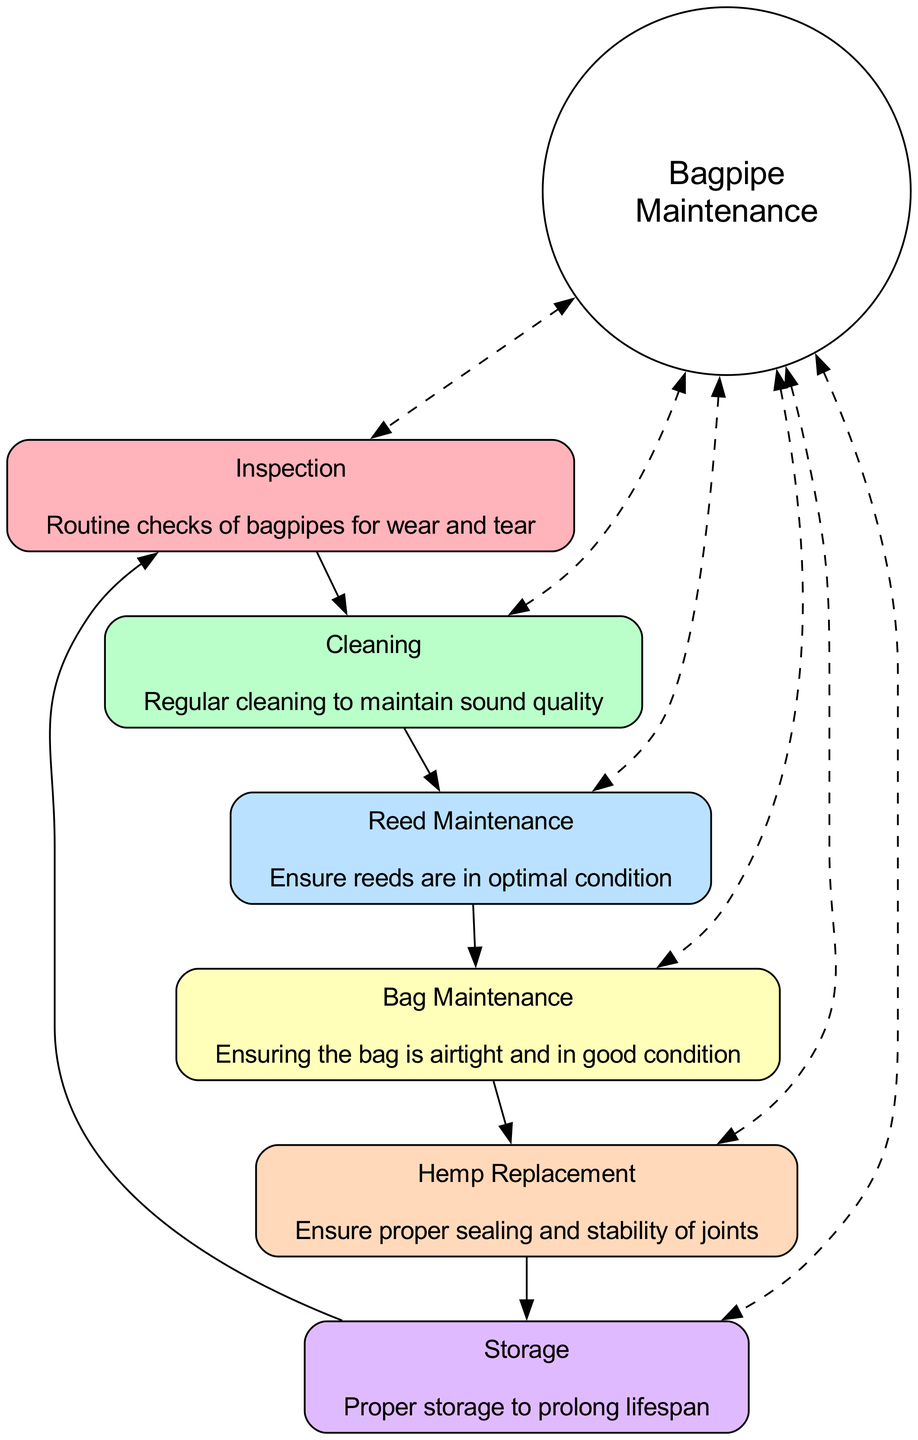What is the first step in the maintenance cycle? The diagram shows that "Inspection" is the first element in the cycle, meaning it is the first step in the maintenance process for bagpipes.
Answer: Inspection How many total elements are in the maintenance cycle? By counting the elements listed in the diagram, there are six key components that make up the maintenance cycle for bagpipes.
Answer: 6 What connects "Bag Maintenance" to "Reed Maintenance"? The diagram depicts an edge connecting "Bag Maintenance" to "Reed Maintenance", indicating that these two steps are directly related in the maintenance cycle.
Answer: Forward edge Which step requires soaking and drying reeds? The "Reed Maintenance" element in the diagram specifies that one of the actions involved is to soak and dry reeds properly, highlighting its importance in maintaining optimal reed condition.
Answer: Reed Maintenance What is the color of the node for "Cleaning"? The node for "Cleaning" is depicted in the light green color from the predefined color palette, specifically the second color on the list.
Answer: BAFFC9 Which action ensures the pipes and bag are free from wear and tear? The "Inspection" step in the cycle includes a key action that focuses on performing routine checks to assess the wear and tear on the bagpipes, ensuring they are in optimal condition.
Answer: Visual inspection of pipes and bag How does "Storage" relate to the overall maintenance cycle? "Storage" is connected to all other nodes through a dashed bi-directional edge from the central "Bagpipe Maintenance" node, indicating that proper storage is an integral aspect of the maintenance cycle that affects all other steps.
Answer: Integral aspect What must be checked during "Bag Maintenance"? One of the essential actions during "Bag Maintenance" is to check for leaks, which is necessary to ensure that the bag remains airtight and effective for play.
Answer: Check for leaks In how many directions do the edges connect the "Maintenance" node to other elements? The edges connecting the "Maintenance" node to each element of the maintenance cycle are bi-directional, thus creating a total direction count of six since there are six edges originating from "Maintenance".
Answer: Bi-directional (6 edges) What is the central theme of this block diagram? The diagram centers around "Bagpipe Maintenance", indicating that all actions and elements are ultimately directed towards maintaining the bagpipes effectively.
Answer: Bagpipe Maintenance 